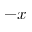Convert formula to latex. <formula><loc_0><loc_0><loc_500><loc_500>- x</formula> 